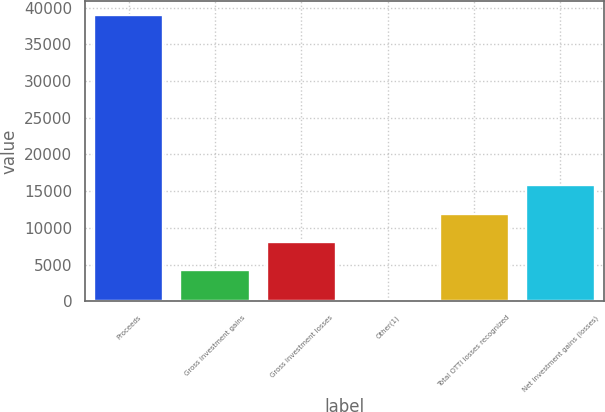<chart> <loc_0><loc_0><loc_500><loc_500><bar_chart><fcel>Proceeds<fcel>Gross investment gains<fcel>Gross investment losses<fcel>Other(1)<fcel>Total OTTI losses recognized<fcel>Net investment gains (losses)<nl><fcel>38972<fcel>4223.9<fcel>8084.8<fcel>363<fcel>11945.7<fcel>15806.6<nl></chart> 